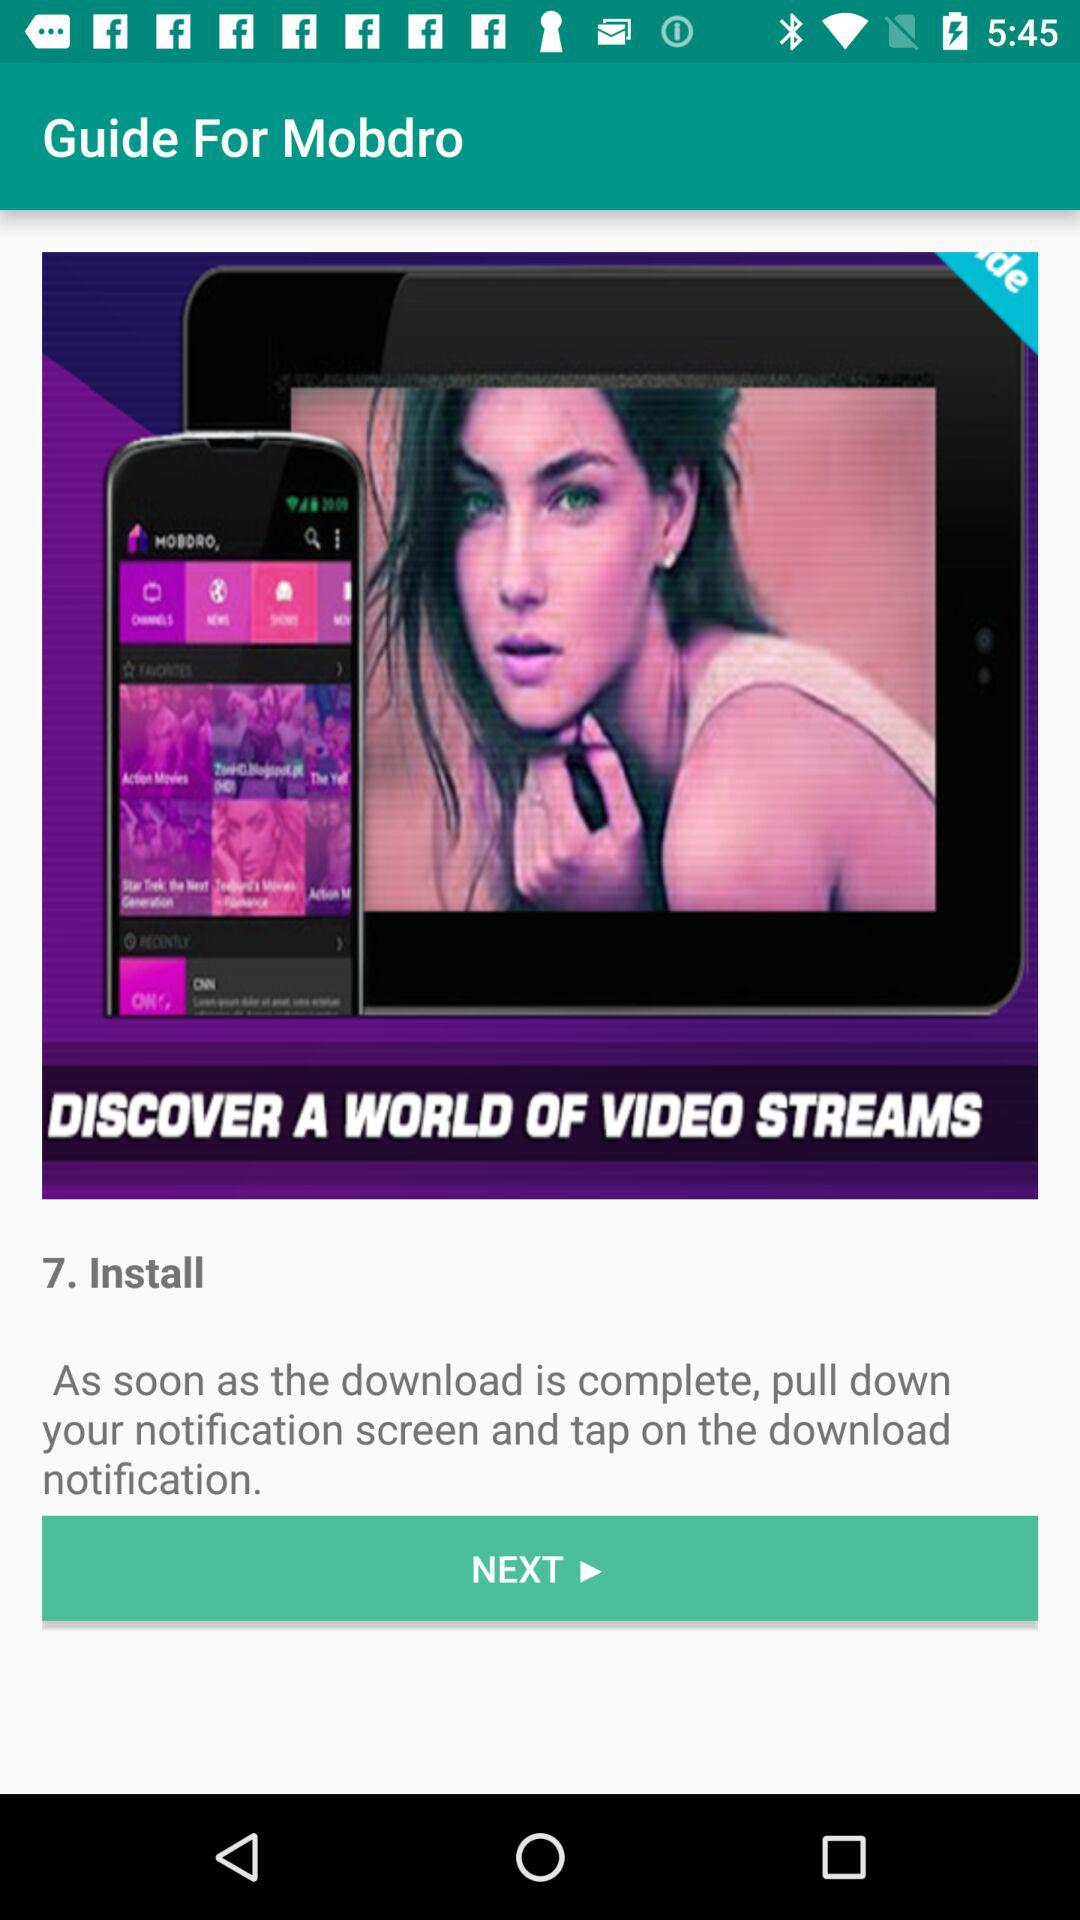How many steps are there in the guide?
Answer the question using a single word or phrase. 7 